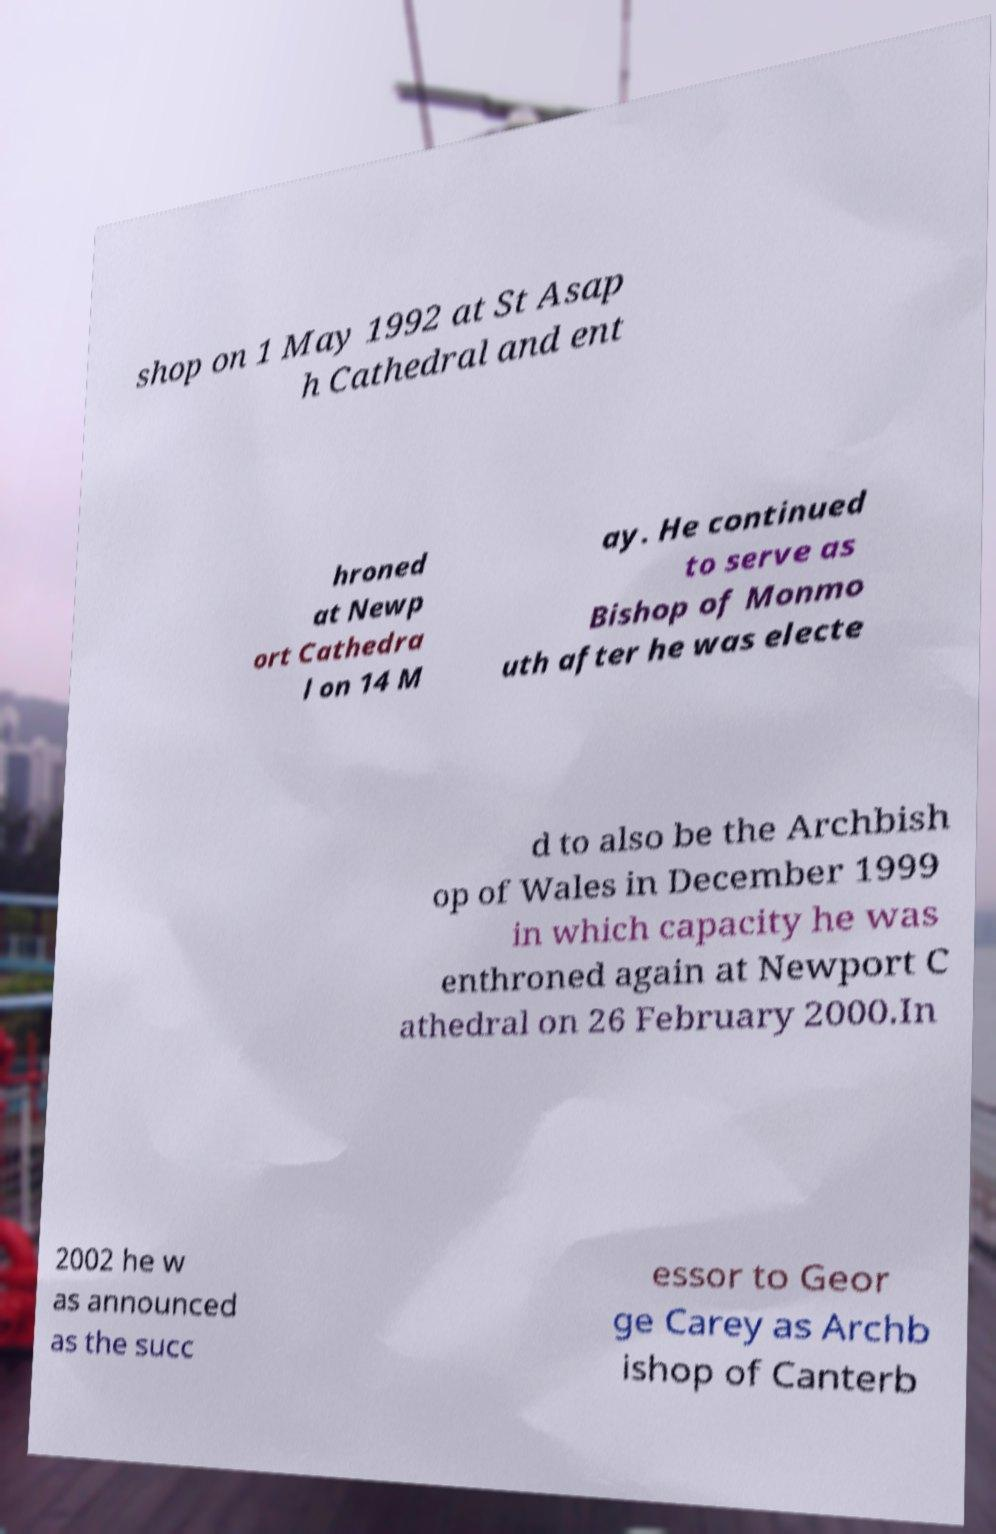Can you read and provide the text displayed in the image?This photo seems to have some interesting text. Can you extract and type it out for me? shop on 1 May 1992 at St Asap h Cathedral and ent hroned at Newp ort Cathedra l on 14 M ay. He continued to serve as Bishop of Monmo uth after he was electe d to also be the Archbish op of Wales in December 1999 in which capacity he was enthroned again at Newport C athedral on 26 February 2000.In 2002 he w as announced as the succ essor to Geor ge Carey as Archb ishop of Canterb 